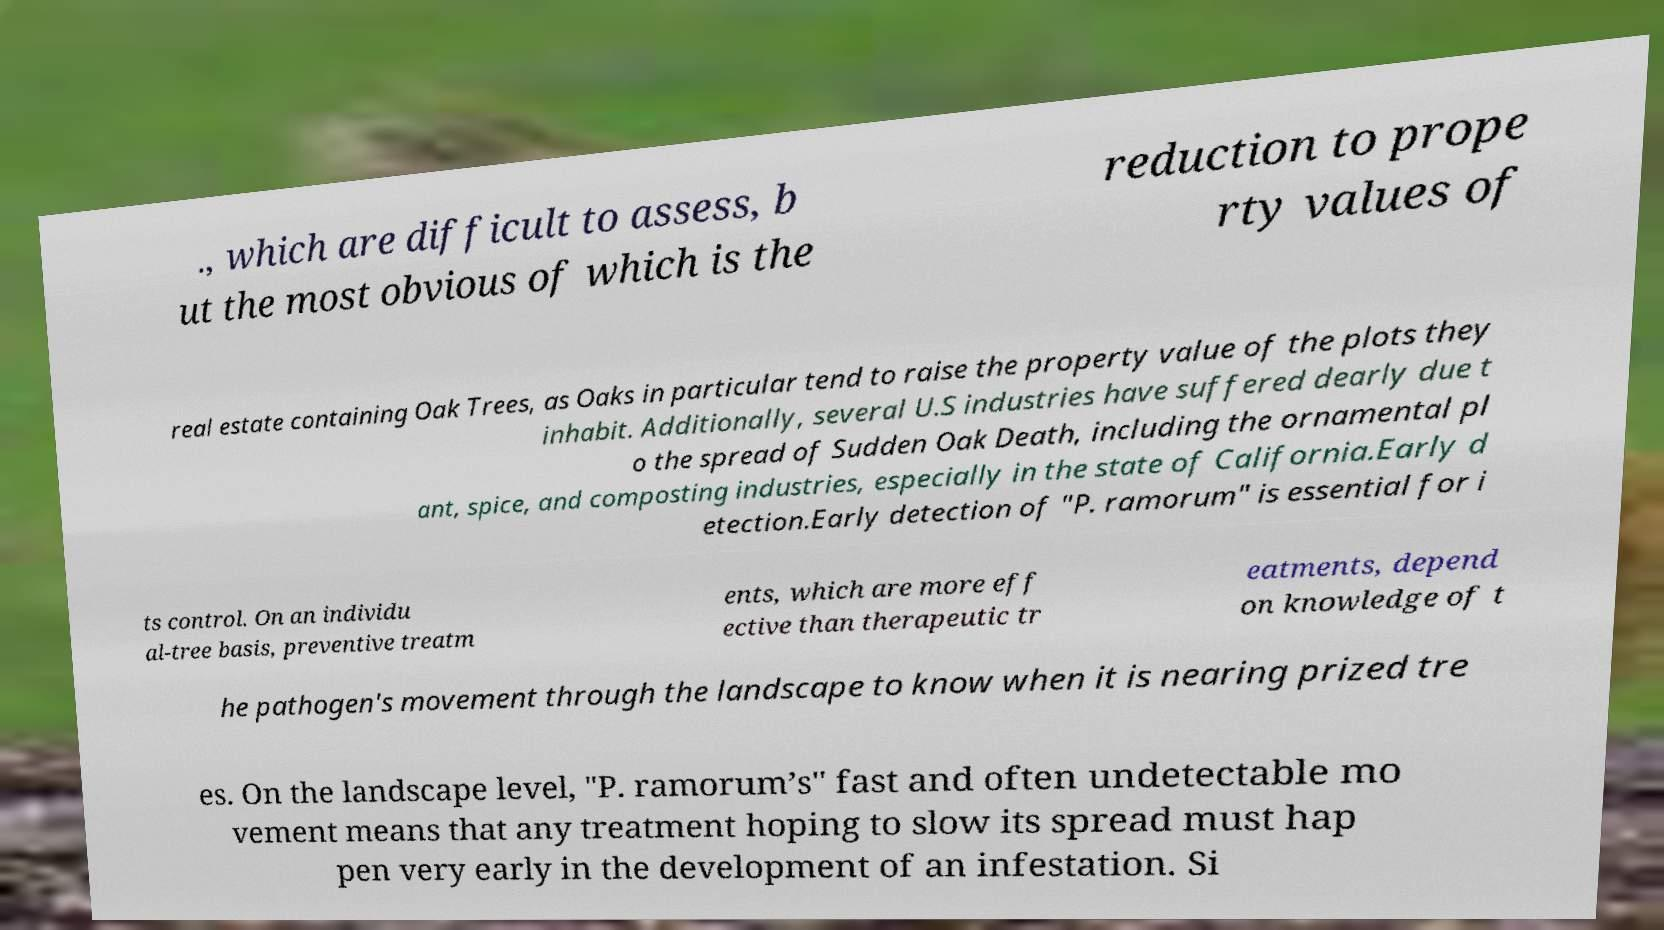Can you read and provide the text displayed in the image?This photo seems to have some interesting text. Can you extract and type it out for me? ., which are difficult to assess, b ut the most obvious of which is the reduction to prope rty values of real estate containing Oak Trees, as Oaks in particular tend to raise the property value of the plots they inhabit. Additionally, several U.S industries have suffered dearly due t o the spread of Sudden Oak Death, including the ornamental pl ant, spice, and composting industries, especially in the state of California.Early d etection.Early detection of "P. ramorum" is essential for i ts control. On an individu al-tree basis, preventive treatm ents, which are more eff ective than therapeutic tr eatments, depend on knowledge of t he pathogen's movement through the landscape to know when it is nearing prized tre es. On the landscape level, "P. ramorum’s" fast and often undetectable mo vement means that any treatment hoping to slow its spread must hap pen very early in the development of an infestation. Si 